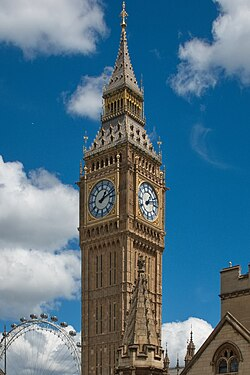Could the clock tower play a role in a fictional story? Absolutely, the clock tower could be central to a gripping fictional narrative. Imagine a tale where Big Ben holds the key to a mysterious, ancient secret. The protagonist discovers that the clock's chimes resonate with a hidden, mythological power capable of controlling time itself. As the story unfolds, our hero embarks on a quest to decipher cryptic messages that appear on the clock faces at certain times of the day. This journey takes them through secret passages within the tower, battling guardians of time and solving puzzles left by a long-forgotten society. The climax could see an epic showdown atop the tower during a thunderstorm, where the protagonist must decide whether to wield this time-controlling power for good or risk altering the course of history forever. 